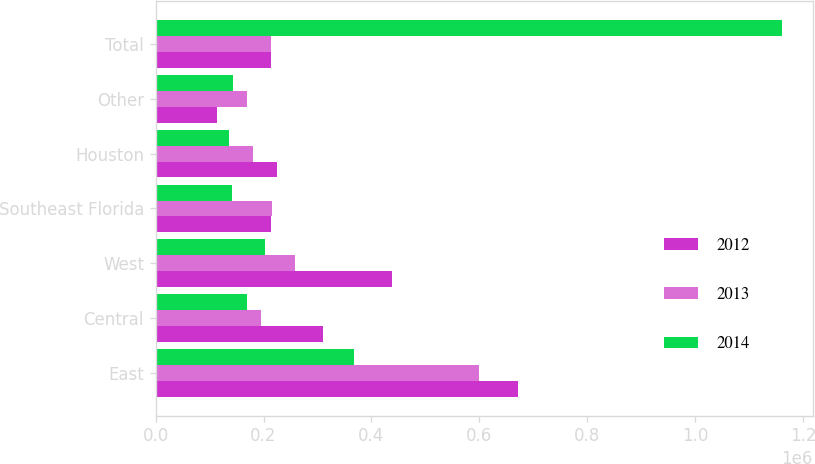Convert chart. <chart><loc_0><loc_0><loc_500><loc_500><stacked_bar_chart><ecel><fcel>East<fcel>Central<fcel>West<fcel>Southeast Florida<fcel>Houston<fcel>Other<fcel>Total<nl><fcel>2012<fcel>672204<fcel>310726<fcel>437492<fcel>214606<fcel>225737<fcel>113563<fcel>214606<nl><fcel>2013<fcel>600257<fcel>195762<fcel>257498<fcel>215988<fcel>180665<fcel>169431<fcel>214606<nl><fcel>2014<fcel>368361<fcel>168912<fcel>202959<fcel>141146<fcel>135282<fcel>143725<fcel>1.16038e+06<nl></chart> 